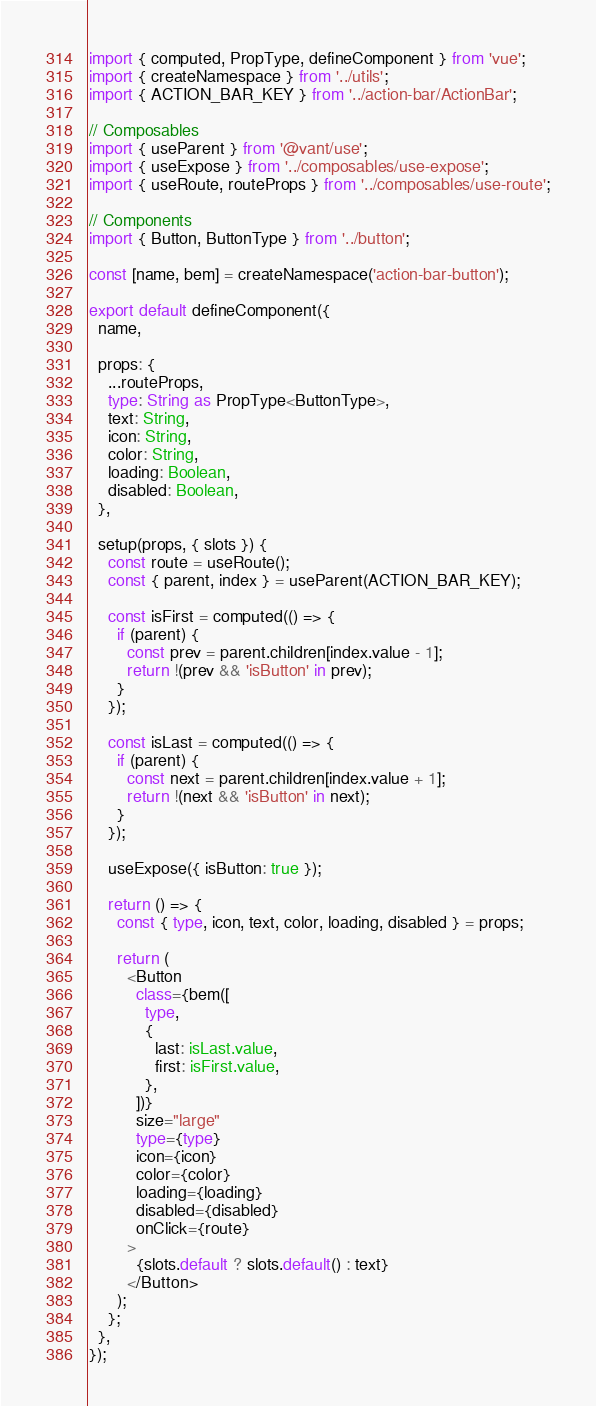<code> <loc_0><loc_0><loc_500><loc_500><_TypeScript_>import { computed, PropType, defineComponent } from 'vue';
import { createNamespace } from '../utils';
import { ACTION_BAR_KEY } from '../action-bar/ActionBar';

// Composables
import { useParent } from '@vant/use';
import { useExpose } from '../composables/use-expose';
import { useRoute, routeProps } from '../composables/use-route';

// Components
import { Button, ButtonType } from '../button';

const [name, bem] = createNamespace('action-bar-button');

export default defineComponent({
  name,

  props: {
    ...routeProps,
    type: String as PropType<ButtonType>,
    text: String,
    icon: String,
    color: String,
    loading: Boolean,
    disabled: Boolean,
  },

  setup(props, { slots }) {
    const route = useRoute();
    const { parent, index } = useParent(ACTION_BAR_KEY);

    const isFirst = computed(() => {
      if (parent) {
        const prev = parent.children[index.value - 1];
        return !(prev && 'isButton' in prev);
      }
    });

    const isLast = computed(() => {
      if (parent) {
        const next = parent.children[index.value + 1];
        return !(next && 'isButton' in next);
      }
    });

    useExpose({ isButton: true });

    return () => {
      const { type, icon, text, color, loading, disabled } = props;

      return (
        <Button
          class={bem([
            type,
            {
              last: isLast.value,
              first: isFirst.value,
            },
          ])}
          size="large"
          type={type}
          icon={icon}
          color={color}
          loading={loading}
          disabled={disabled}
          onClick={route}
        >
          {slots.default ? slots.default() : text}
        </Button>
      );
    };
  },
});
</code> 